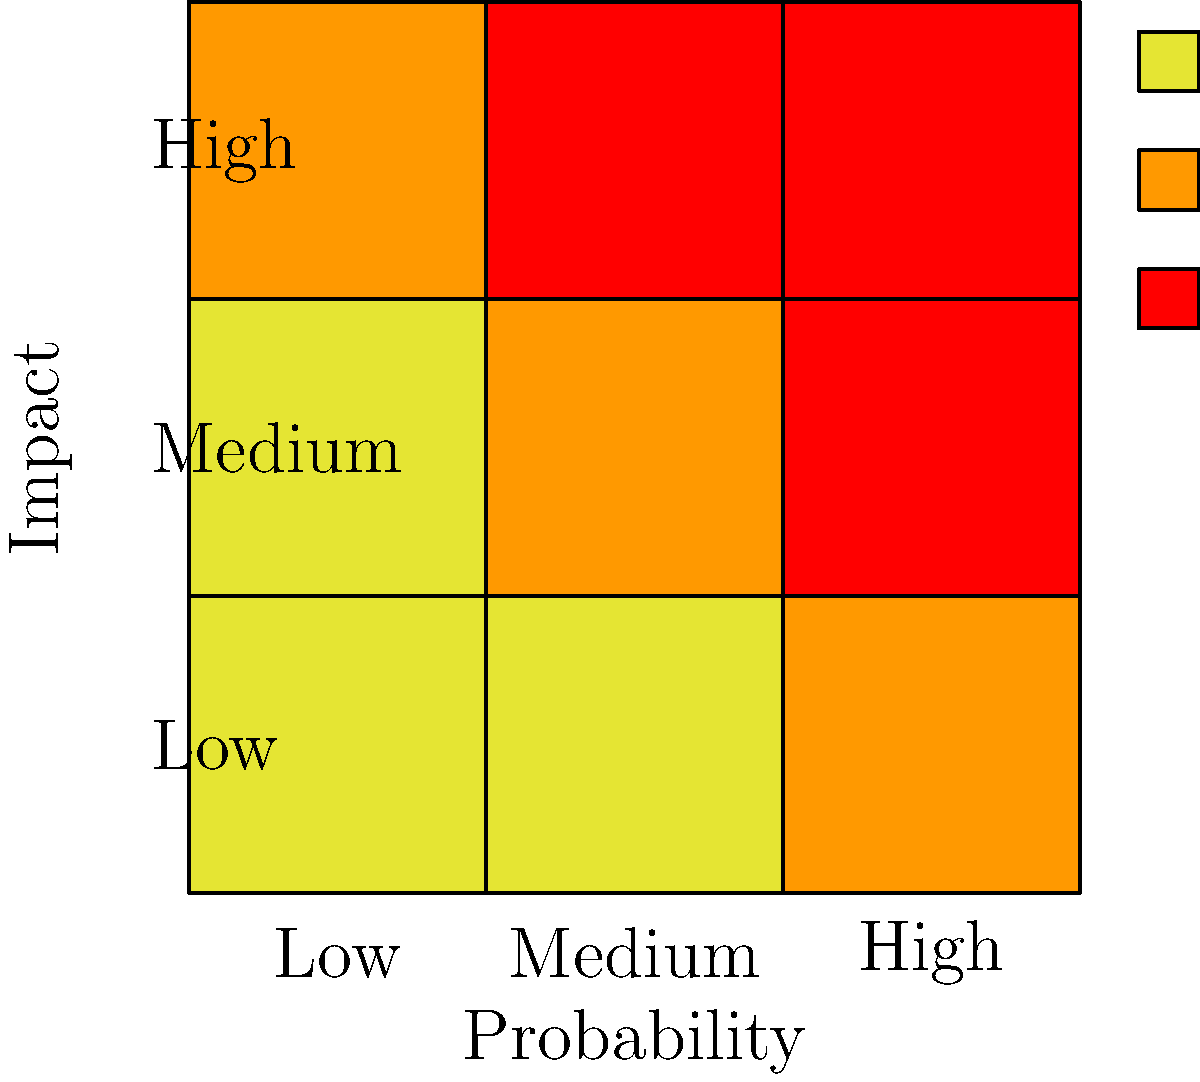As a managerial professional, you're reviewing a risk matrix for a new project. Risk X has been identified and placed on the matrix as shown. Based on its position, what priority level should be assigned to Risk X, and what general approach should be taken for its mitigation? To determine the priority level and mitigation approach for Risk X, let's analyze its position on the risk matrix:

1. Understand the risk matrix:
   - The horizontal axis represents probability (likelihood of occurrence)
   - The vertical axis represents impact (severity of consequences)
   - The colors indicate risk levels: yellow (low), orange (medium), red (high)

2. Locate Risk X:
   - Risk X is positioned at the intersection of high probability and medium impact

3. Determine the risk level:
   - The cell containing Risk X is colored red, indicating a high-risk level

4. Assign priority:
   - High-risk items should be given high priority in risk management

5. General mitigation approach:
   - For high-risk items, a proactive and robust mitigation strategy is necessary
   - This typically involves developing detailed action plans to reduce probability and/or impact
   - Regular monitoring and reporting on the risk status should be implemented
   - Contingency plans should be prepared in case the risk materializes

6. Considerations for the managerial role:
   - Allocate appropriate resources for mitigation efforts
   - Ensure clear communication with the senior engineer about technical aspects and feasibility of mitigation strategies
   - Regularly review and update the risk assessment with the project team

Given the high-risk classification, Risk X should be treated as a top priority, requiring immediate attention and a comprehensive mitigation strategy to ensure project success.
Answer: High priority; implement comprehensive mitigation strategy with regular monitoring and contingency planning. 